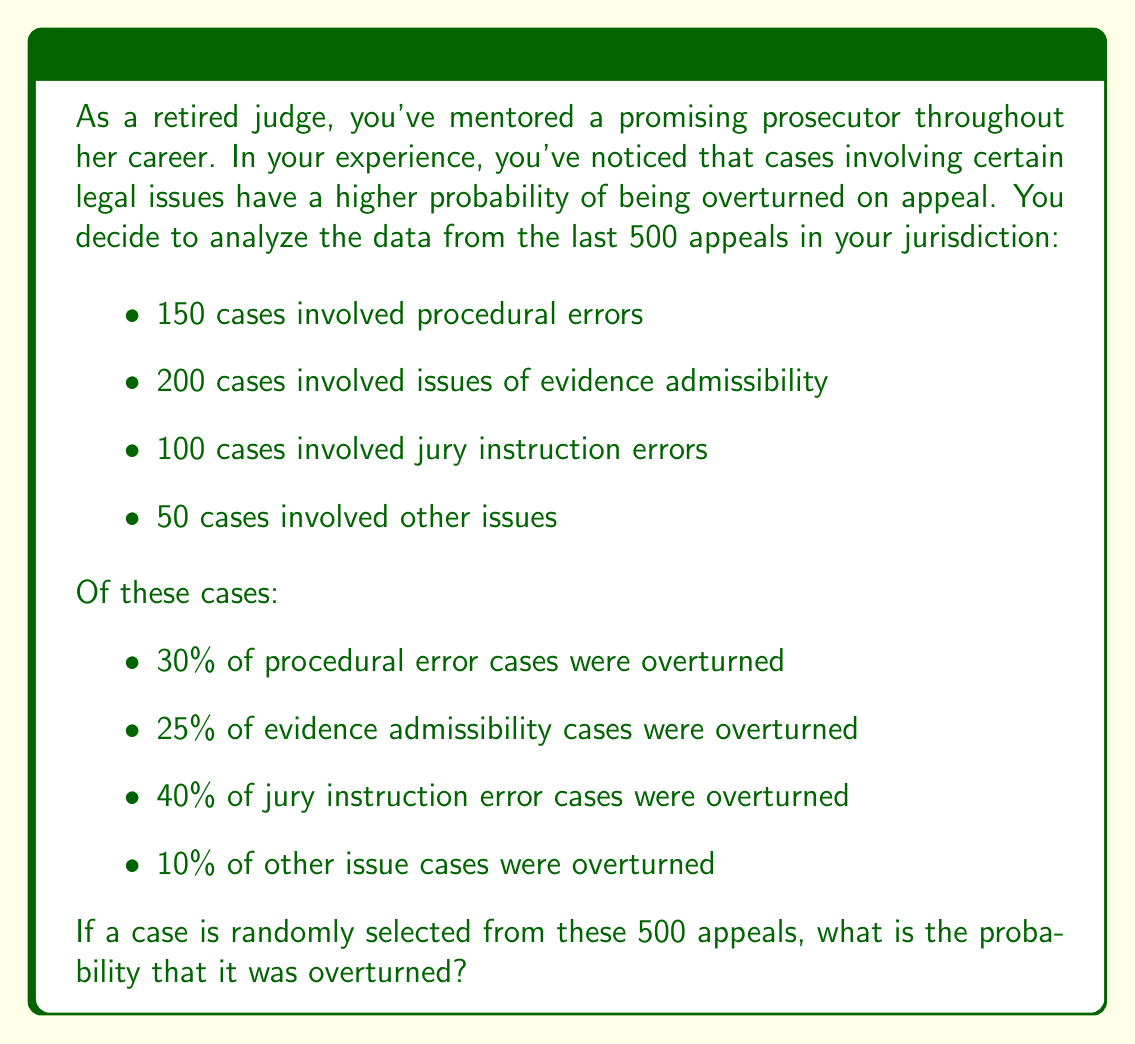Provide a solution to this math problem. To solve this problem, we'll use the law of total probability. Let's break it down step by step:

1) First, let's define our events:
   A = case is overturned
   P = case involves procedural errors
   E = case involves evidence admissibility issues
   J = case involves jury instruction errors
   O = case involves other issues

2) We can calculate the probability of each type of case:
   $P(P) = 150/500 = 0.3$
   $P(E) = 200/500 = 0.4$
   $P(J) = 100/500 = 0.2$
   $P(O) = 50/500 = 0.1$

3) We're given the conditional probabilities of a case being overturned for each type:
   $P(A|P) = 0.30$
   $P(A|E) = 0.25$
   $P(A|J) = 0.40$
   $P(A|O) = 0.10$

4) Using the law of total probability:
   $$P(A) = P(A|P)P(P) + P(A|E)P(E) + P(A|J)P(J) + P(A|O)P(O)$$

5) Substituting our values:
   $$P(A) = (0.30)(0.3) + (0.25)(0.4) + (0.40)(0.2) + (0.10)(0.1)$$

6) Calculating:
   $$P(A) = 0.09 + 0.10 + 0.08 + 0.01 = 0.28$$

Therefore, the probability that a randomly selected case was overturned is 0.28 or 28%.
Answer: The probability that a randomly selected case was overturned is 0.28 or 28%. 